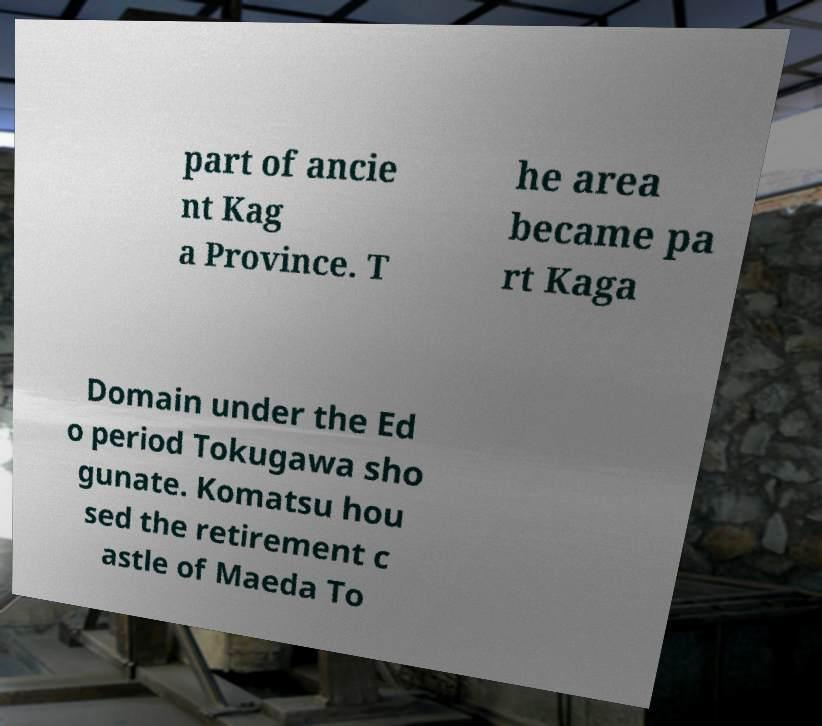Please identify and transcribe the text found in this image. part of ancie nt Kag a Province. T he area became pa rt Kaga Domain under the Ed o period Tokugawa sho gunate. Komatsu hou sed the retirement c astle of Maeda To 